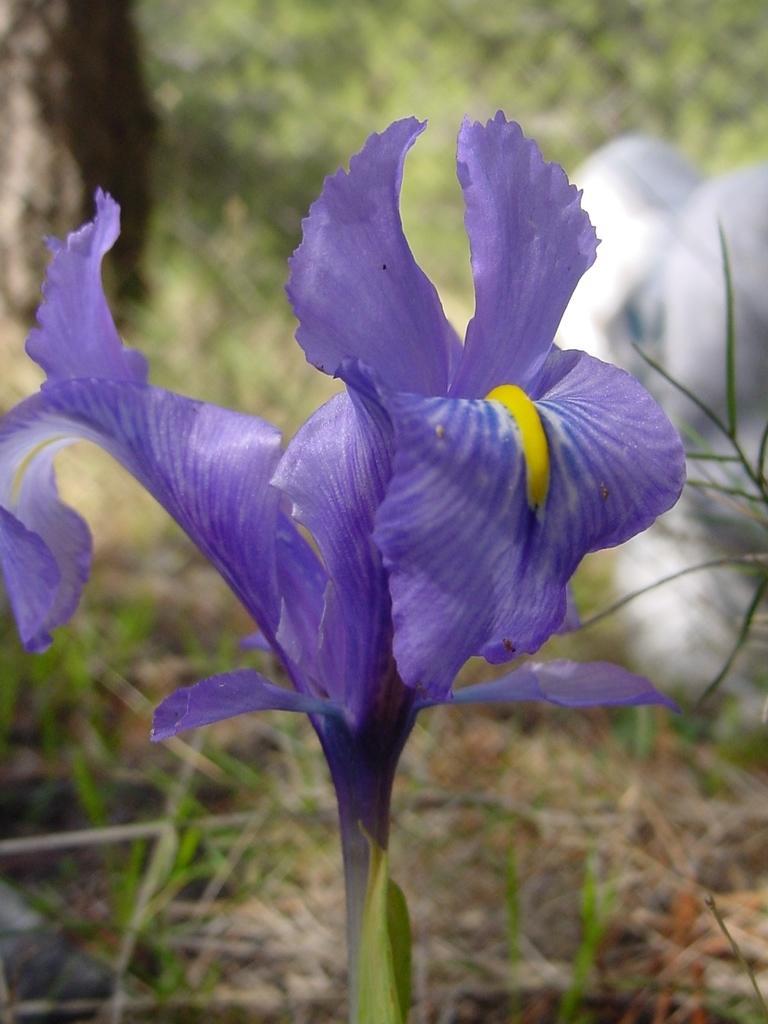Describe this image in one or two sentences. In the foreground there is a flower to a stem. The petals are in blue color. In the background there are many plants. On the right side there is a white color object. 